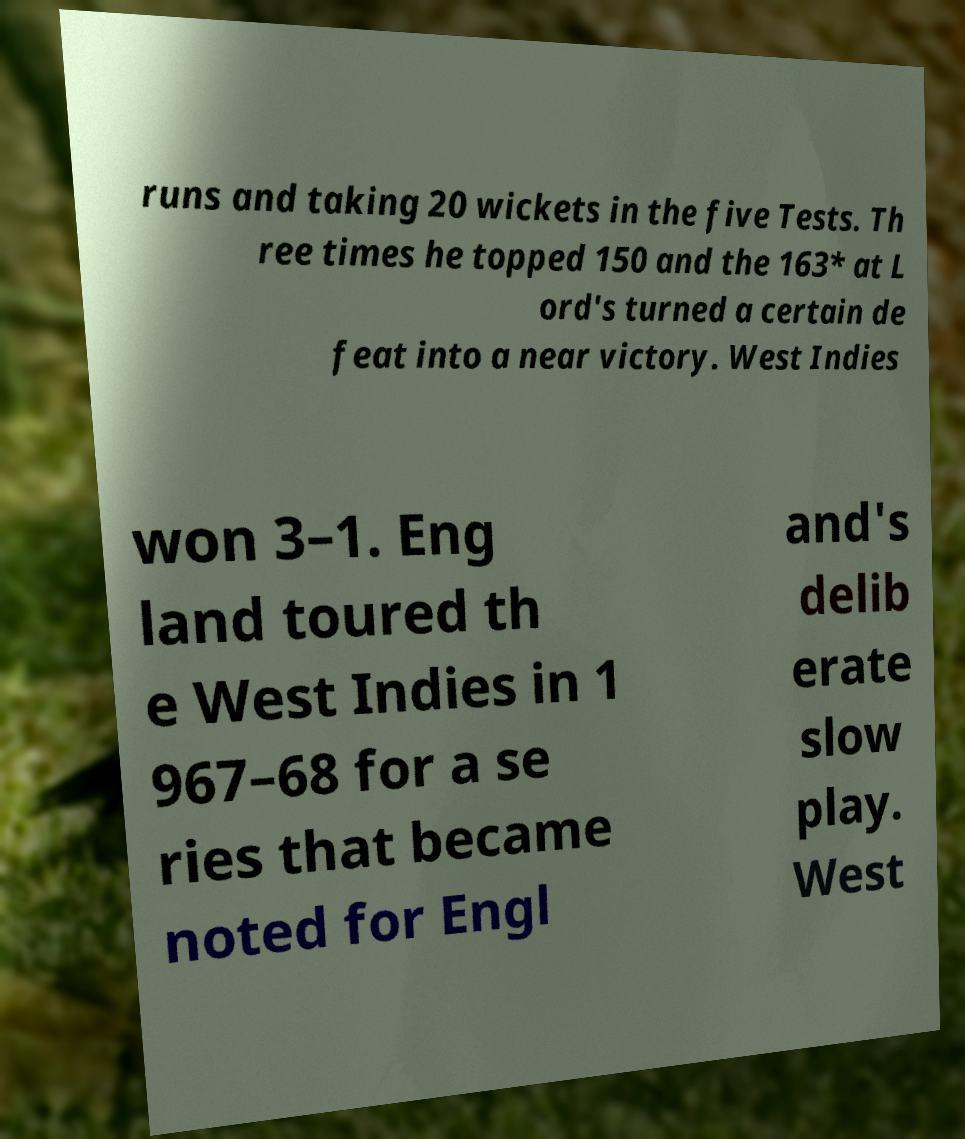Can you accurately transcribe the text from the provided image for me? runs and taking 20 wickets in the five Tests. Th ree times he topped 150 and the 163* at L ord's turned a certain de feat into a near victory. West Indies won 3–1. Eng land toured th e West Indies in 1 967–68 for a se ries that became noted for Engl and's delib erate slow play. West 